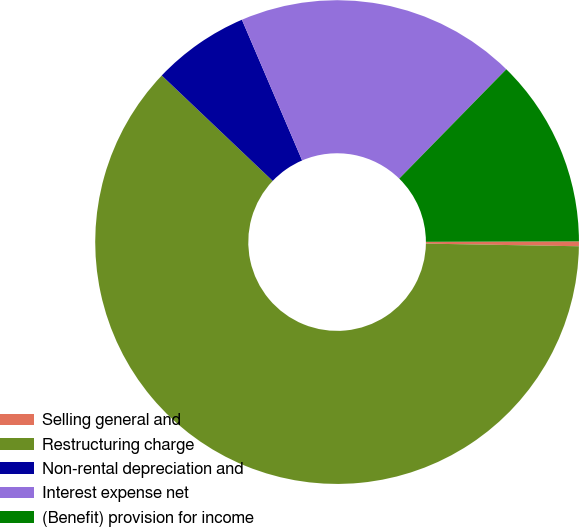<chart> <loc_0><loc_0><loc_500><loc_500><pie_chart><fcel>Selling general and<fcel>Restructuring charge<fcel>Non-rental depreciation and<fcel>Interest expense net<fcel>(Benefit) provision for income<nl><fcel>0.32%<fcel>61.81%<fcel>6.47%<fcel>18.77%<fcel>12.62%<nl></chart> 